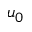Convert formula to latex. <formula><loc_0><loc_0><loc_500><loc_500>u _ { 0 }</formula> 